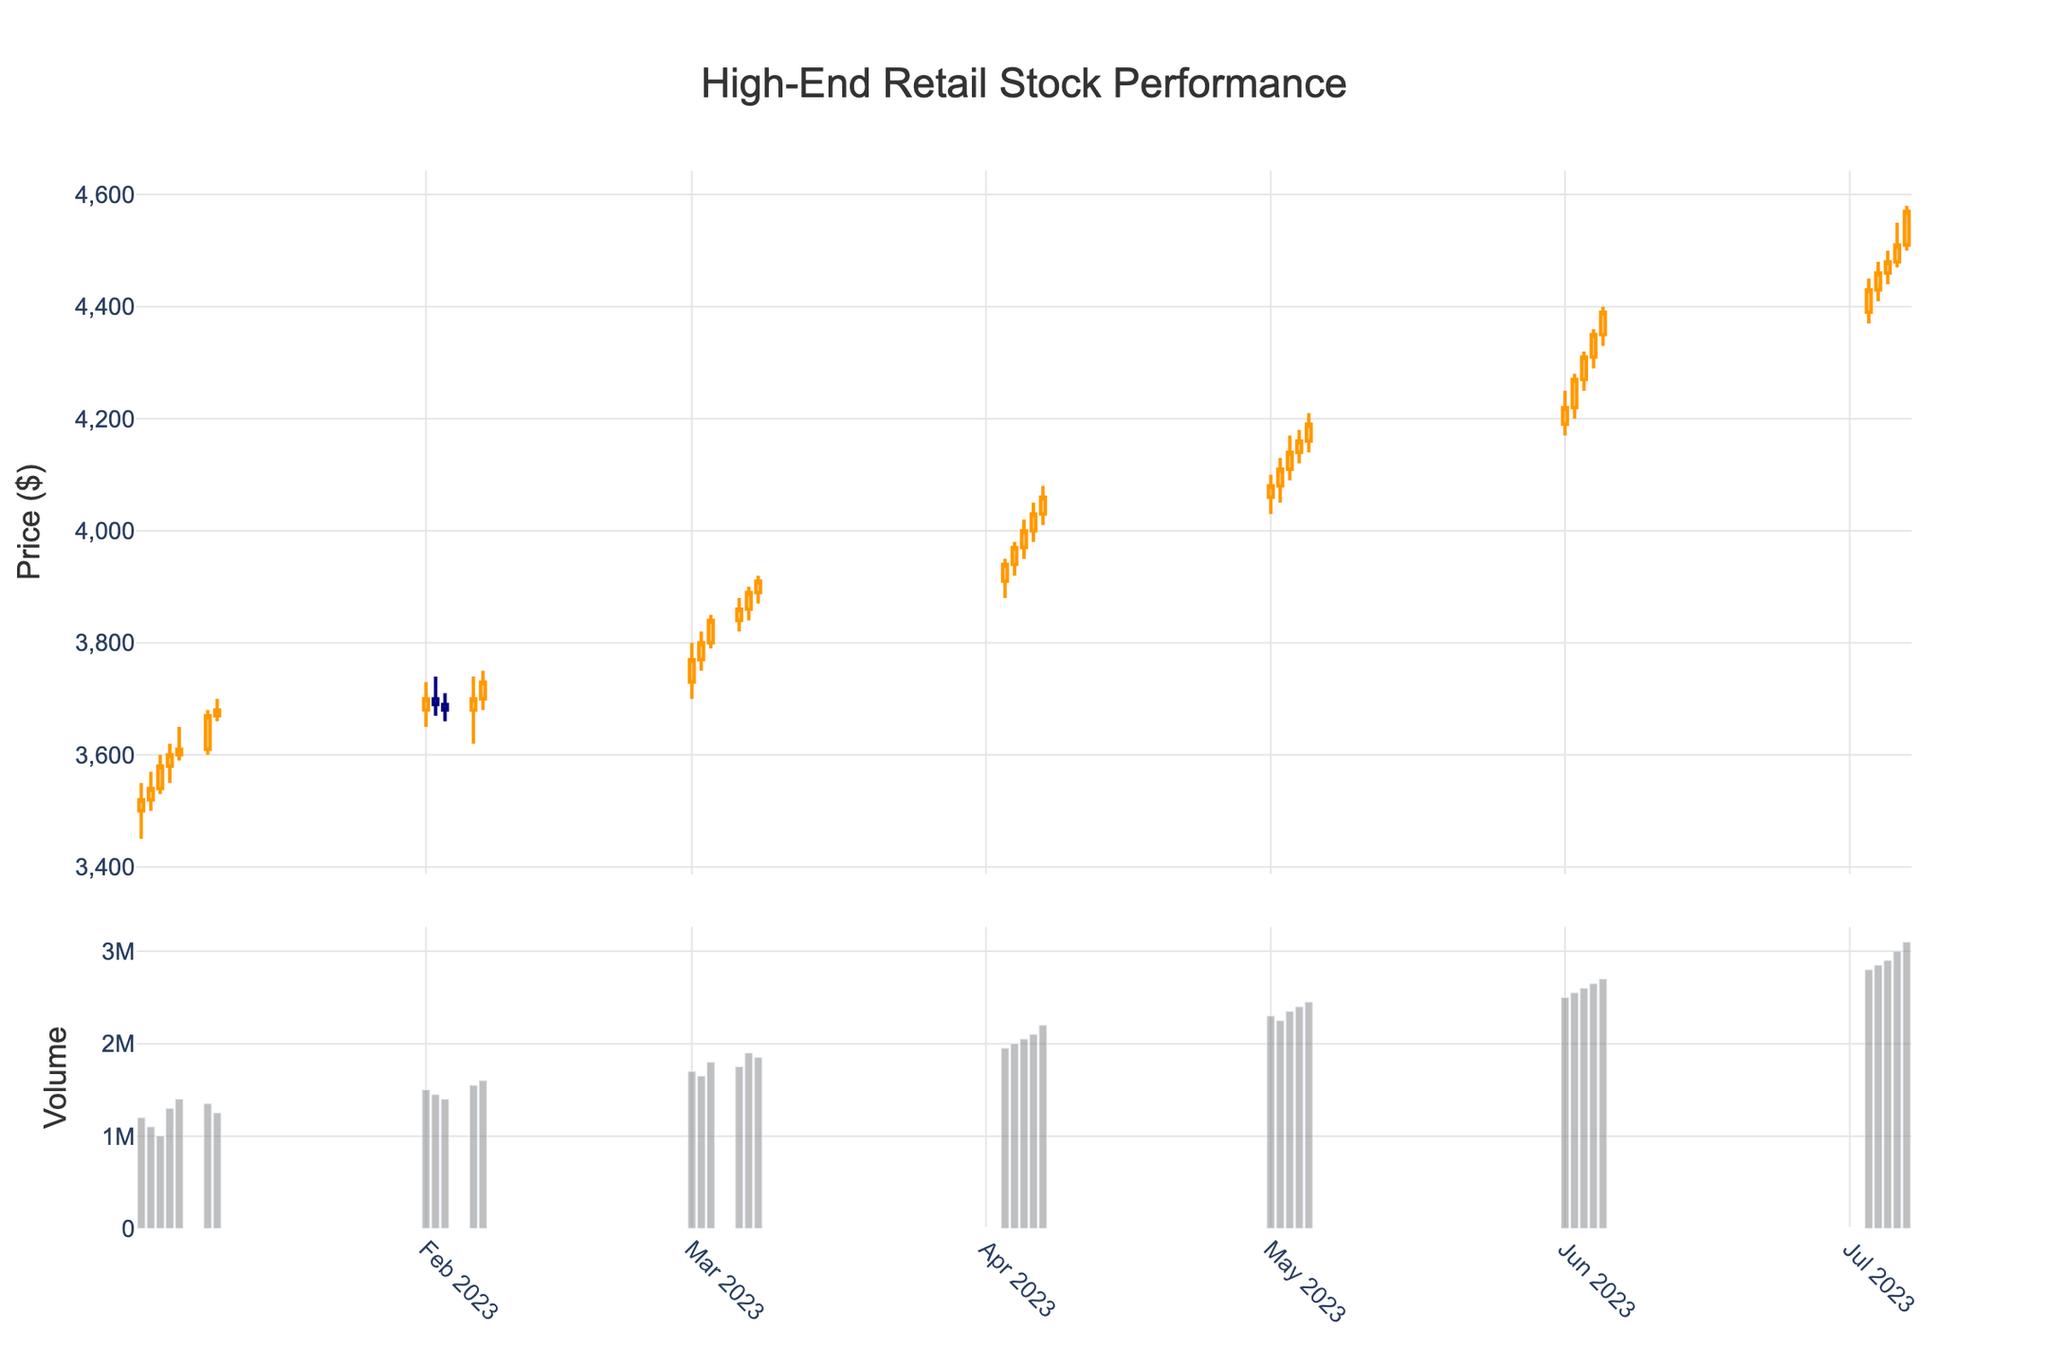What is the highest price reached by the stock in the data shown? The highest price reached by the stock can be identified by looking at the highest point in the 'High' data of the candlestick plot. According to the data, the highest price is $4580, which occurred on 2023-07-07.
Answer: 4580 How many data points are represented in the plot? Each row of the data represents a data point. By counting the total number of rows in the given data, we see that there are 35 data points shown in the plot.
Answer: 35 How did the stock price trend in January 2023? To determine the trend for January, look at the closing prices for the dates in January. The stock price started at $3520 on January 2nd and closed at $3680 on January 10th. This indicates an upward trend in January 2023.
Answer: Upward What was the volume on the day with the highest closing price in April 2023? The highest closing price in April 2023 can be found by identifying the highest closing value for the dates within April. The highest was $4060 on April 7th. The corresponding volume was 2200000.
Answer: 2200000 Compare the volume trends between February and March 2023. To compare the volume trends between February and March, look at the volume bars for those months. Generally, the volume in March (ranging up to 1900000) is consistently higher than the volume in February (up to 1600000).
Answer: March had higher volume What is the relationship between the highest closing price and the highest trading volume in the dataset? Examine the highest closing price of $4570 on July 7th and the highest volume of 3100000, which occurred on the same date. This suggests that the highest closing price coincided with the highest trading volume within the dataset.
Answer: Both on July 7th How does the stock's performance in June compare to its performance in July? By comparing the closing prices, the stock started June at $4220 and ended at $4390, indicating an upward trend. In July, it started at $4430 and ended at $4570, also showing an upward trend. Both months show an upward trend, but July ended with a higher closing price, continuing the upward momentum from June.
Answer: Both months show uptrend What is the average closing price in March 2023? Sum the closing prices in March (3770, 3800, 3840, 3860, 3890, 3910) which equals 23070, then divide by the number of data points (6). The average closing price for March 2023 is 3845.
Answer: 3845 